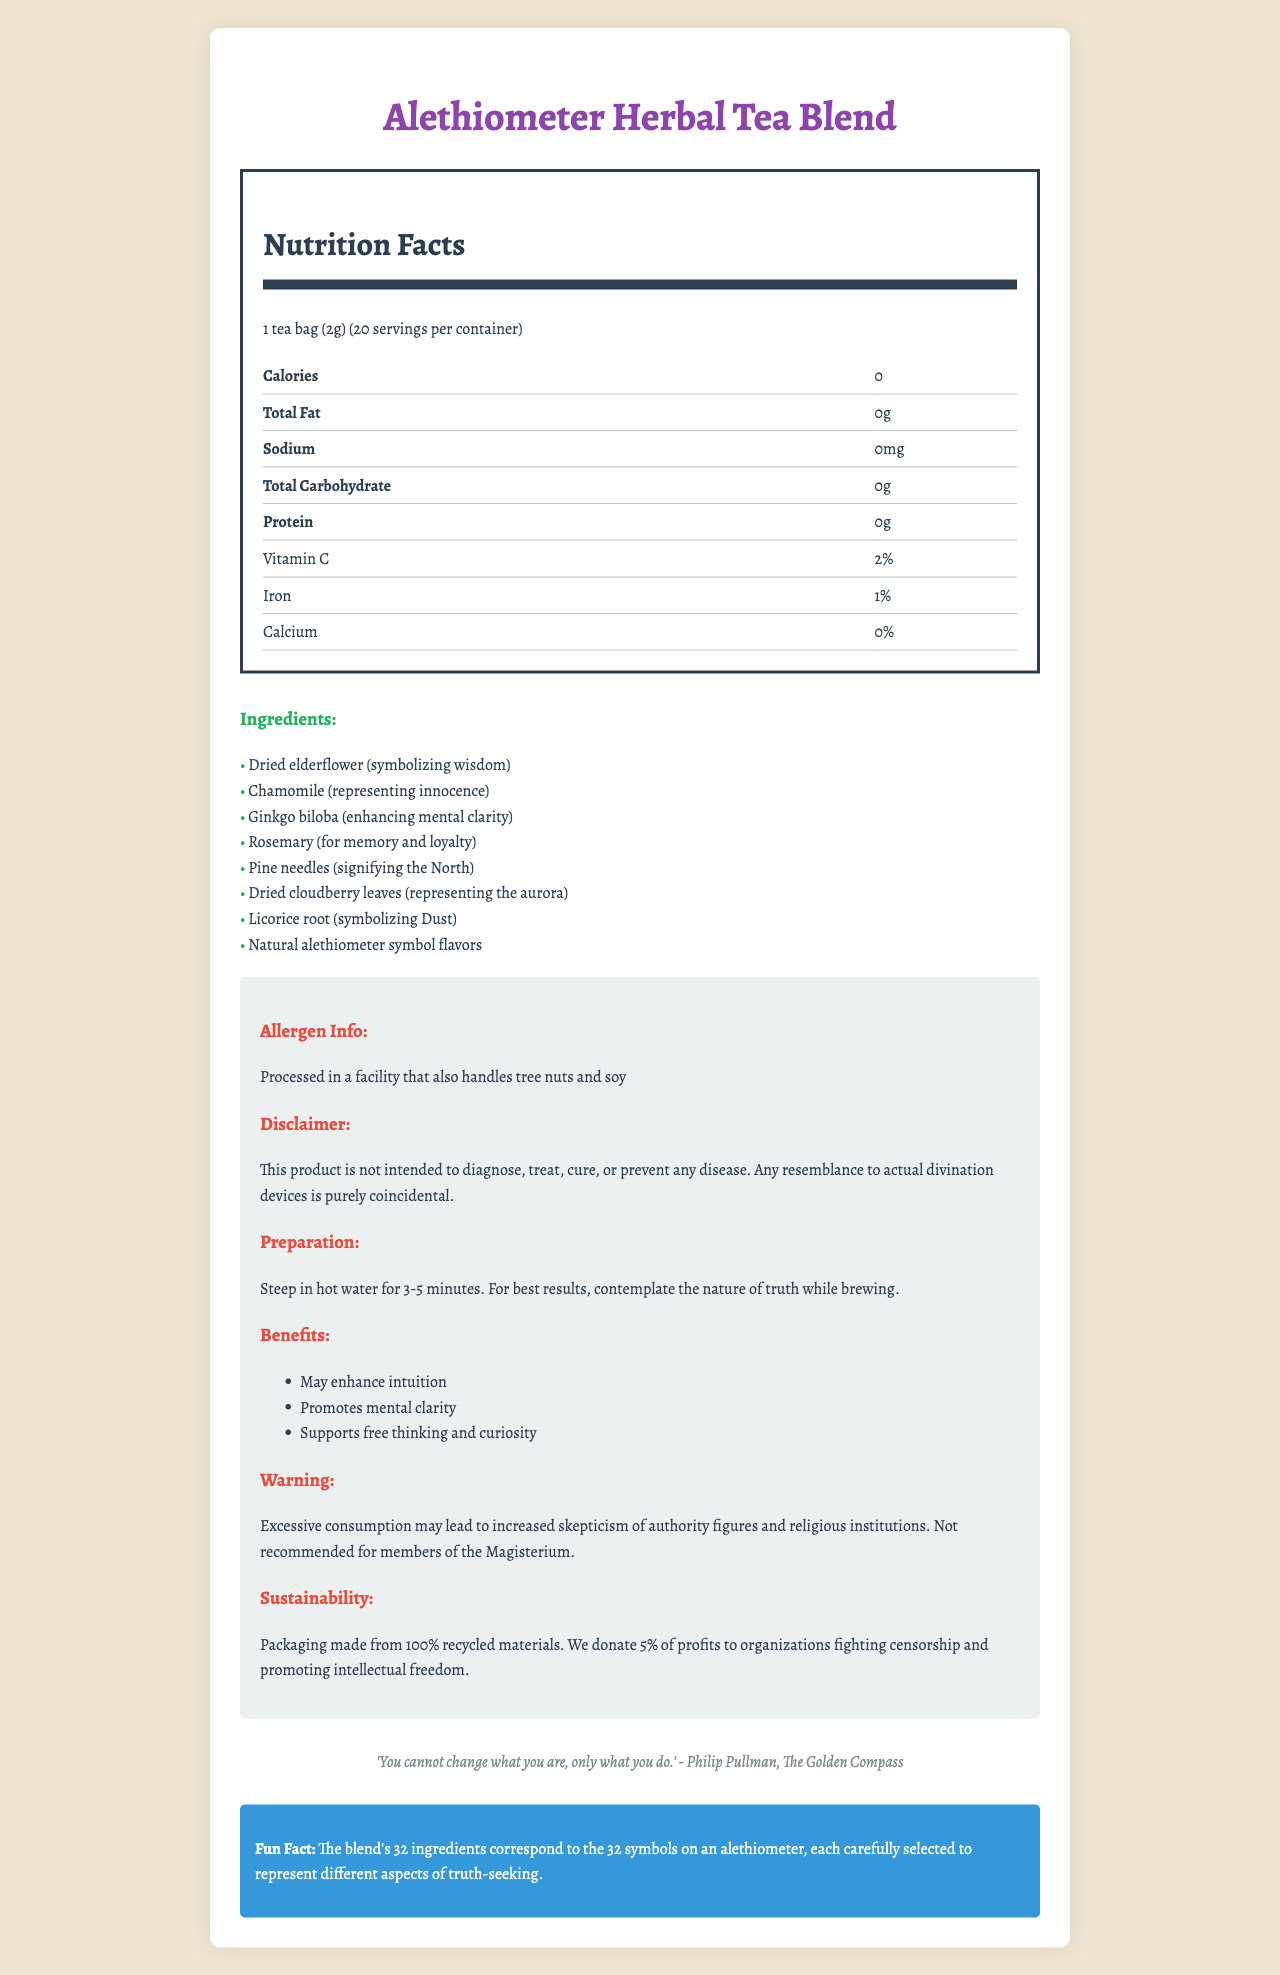what is the serving size for the Alethiometer Herbal Tea Blend? The serving size is explicitly stated in the Nutrition Facts section.
Answer: 1 tea bag (2g) how many servings are there per container? It is mentioned directly under the serving size in the Nutrition Facts section.
Answer: 20 how many calories are in one serving? The number of calories is listed at the top of the Nutrition Facts table.
Answer: 0 which ingredient represents wisdom? It is listed among the ingredients with the note that dried elderflower symbolizes wisdom.
Answer: Dried elderflower what is the sodium content per serving? The sodium content is listed in the Nutrition Facts table.
Answer: 0mg which of the following ingredients is believed to enhance mental clarity? A. Chamomile B. Ginkgo biloba C. Pine needles D. Rosemary Ginkgo biloba is listed among the ingredients with the note that it enhances mental clarity.
Answer: B how much protein is in one serving? A. 0g B. 2g C. 5g D. 7g The Nutrition Facts section shows that there are 0g of protein per serving.
Answer: A is this product intended to diagnose, treat, cure, or prevent any disease? The disclaimer explicitly states this product is not intended for disease-related purposes.
Answer: No does this product contain nuts? While the allergen information mentions tree nuts are handled in the facility, it does not confirm if they are present in the product itself.
Answer: Cannot be determined summarize the main idea of the document. The label outlines the key aspects of the herbal tea blend, including its symbolic ingredients, allergen information, health benefits, and warnings, along with sustainability notes and a relevant quote.
Answer: The document is a detailed Nutrition Facts Label for Alethiometer Herbal Tea Blend, providing information on serving size, ingredients, nutritional content, preparation instructions, benefits, and sustainability. how should the Alethiometer Herbal Tea Blend be prepared? The preparation instructions provided in the extra-info section detail the steeping time and suggest contemplating the nature of truth while brewing.
Answer: Steep in hot water for 3-5 minutes. For best results, contemplate the nature of truth while brewing. what is the potential consequence of excessive consumption? The warning section in the extra-info part of the document specifies this consequence.
Answer: Increased skepticism of authority figures and religious institutions what percentage of profits are donated to organizations fighting censorship and promoting intellectual freedom? The sustainability section mentions that 5% of profits are donated for these causes.
Answer: 5% 